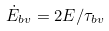<formula> <loc_0><loc_0><loc_500><loc_500>\dot { E } _ { b v } = 2 E / \tau _ { b v }</formula> 